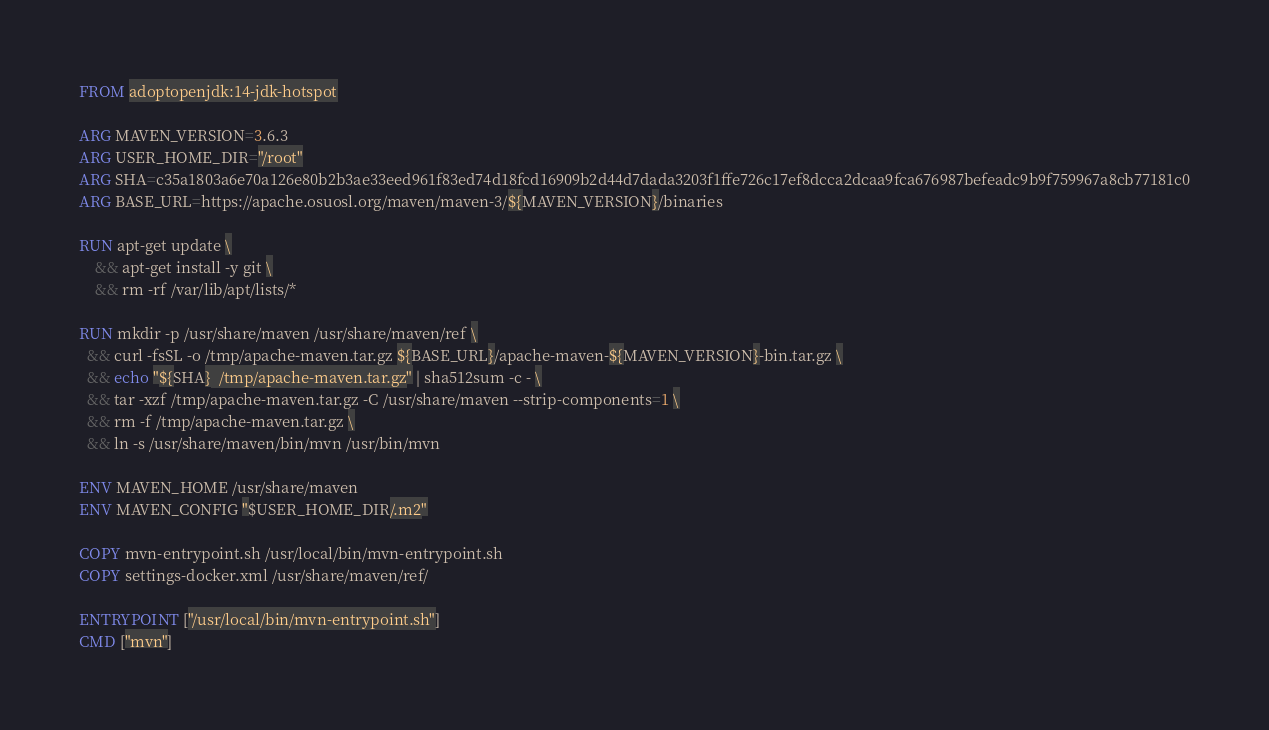<code> <loc_0><loc_0><loc_500><loc_500><_Dockerfile_>FROM adoptopenjdk:14-jdk-hotspot

ARG MAVEN_VERSION=3.6.3
ARG USER_HOME_DIR="/root"
ARG SHA=c35a1803a6e70a126e80b2b3ae33eed961f83ed74d18fcd16909b2d44d7dada3203f1ffe726c17ef8dcca2dcaa9fca676987befeadc9b9f759967a8cb77181c0
ARG BASE_URL=https://apache.osuosl.org/maven/maven-3/${MAVEN_VERSION}/binaries

RUN apt-get update \
    && apt-get install -y git \
    && rm -rf /var/lib/apt/lists/*

RUN mkdir -p /usr/share/maven /usr/share/maven/ref \
  && curl -fsSL -o /tmp/apache-maven.tar.gz ${BASE_URL}/apache-maven-${MAVEN_VERSION}-bin.tar.gz \
  && echo "${SHA}  /tmp/apache-maven.tar.gz" | sha512sum -c - \
  && tar -xzf /tmp/apache-maven.tar.gz -C /usr/share/maven --strip-components=1 \
  && rm -f /tmp/apache-maven.tar.gz \
  && ln -s /usr/share/maven/bin/mvn /usr/bin/mvn

ENV MAVEN_HOME /usr/share/maven
ENV MAVEN_CONFIG "$USER_HOME_DIR/.m2"

COPY mvn-entrypoint.sh /usr/local/bin/mvn-entrypoint.sh
COPY settings-docker.xml /usr/share/maven/ref/

ENTRYPOINT ["/usr/local/bin/mvn-entrypoint.sh"]
CMD ["mvn"]
</code> 